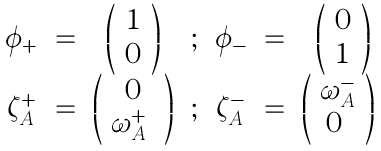Convert formula to latex. <formula><loc_0><loc_0><loc_500><loc_500>\begin{array} { c c c c c c c } \phi _ { + } & = & \left ( \begin{array} { c } 1 \\ 0 \\ \end{array} \right ) & ; & \phi _ { - } & = & \left ( \begin{array} { c } 0 \\ 1 \\ \end{array} \right ) \\ \zeta _ { A } ^ { + } & = & \left ( \begin{array} { c } 0 \\ \omega ^ { + } _ { A } \ \end{array} \right ) & ; & \zeta _ { A } ^ { - } & = & \left ( \begin{array} { c } \omega _ { A } ^ { - } \\ 0 \ \end{array} \right ) \ \end{array}</formula> 